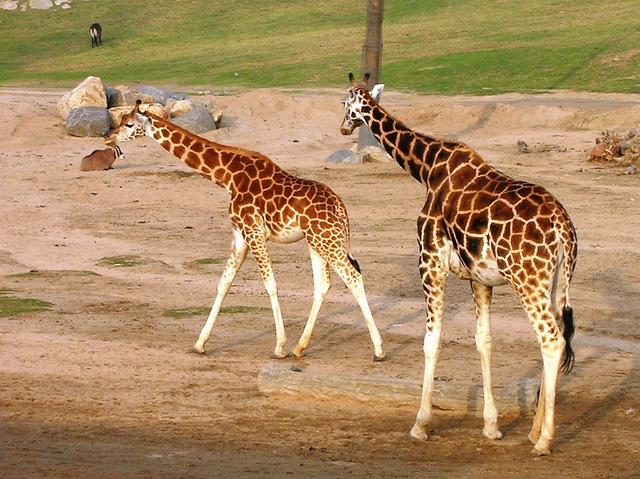How many giraffes are there?
Answer briefly. 2. What color ares the giraffes?
Be succinct. Brown and tan. Are these giraffes in a zoo?
Quick response, please. Yes. 